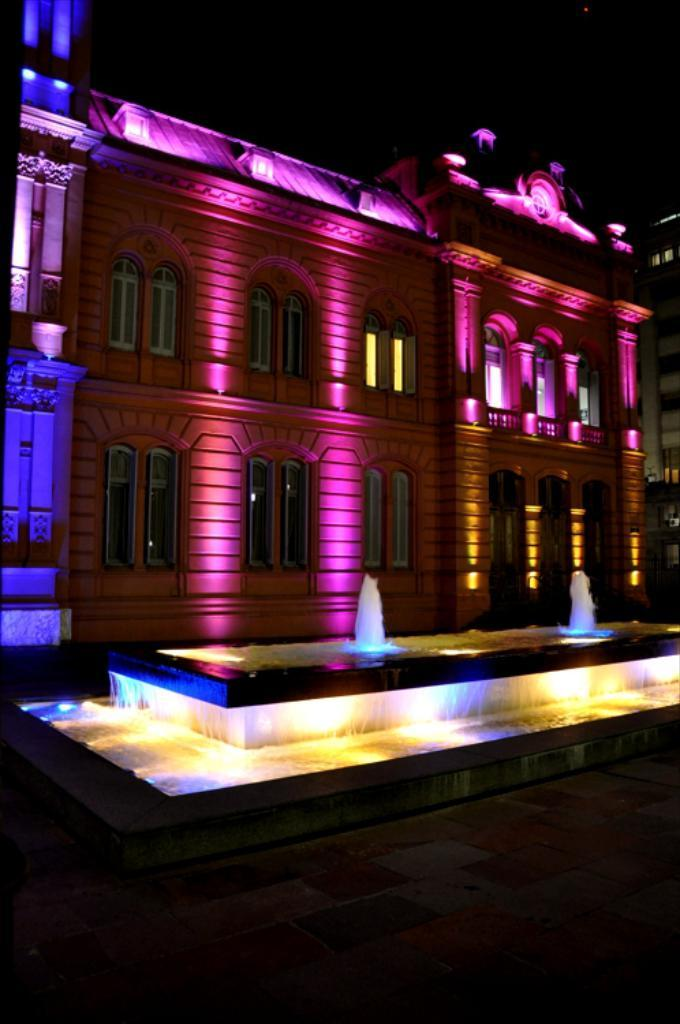What time of day was the image taken? The image was taken during night time. What can be seen in the background of the image? There are buildings with lightning in the image. What is a feature visible in the foreground of the image? There is a water fountain visible in the image. Is there any indication of a path or walkway in the image? Yes, there is a path in the image. What type of cabbage is growing on the side of the path in the image? There is no cabbage present in the image; it is a nighttime scene with buildings, lightning, a water fountain, and a path. 